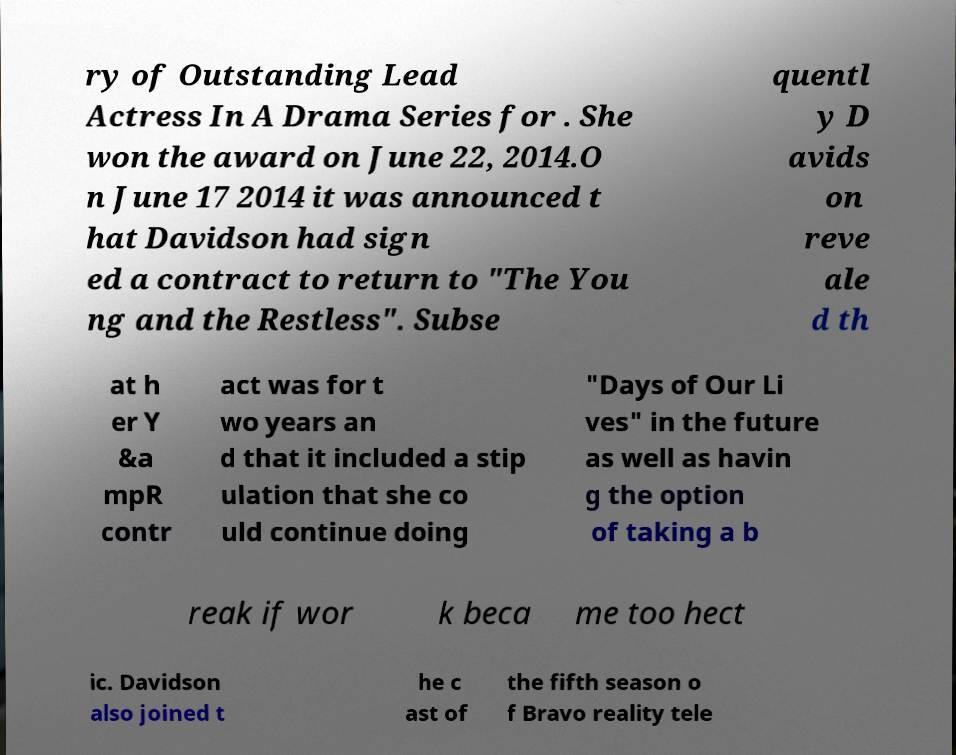Please read and relay the text visible in this image. What does it say? ry of Outstanding Lead Actress In A Drama Series for . She won the award on June 22, 2014.O n June 17 2014 it was announced t hat Davidson had sign ed a contract to return to "The You ng and the Restless". Subse quentl y D avids on reve ale d th at h er Y &a mpR contr act was for t wo years an d that it included a stip ulation that she co uld continue doing "Days of Our Li ves" in the future as well as havin g the option of taking a b reak if wor k beca me too hect ic. Davidson also joined t he c ast of the fifth season o f Bravo reality tele 